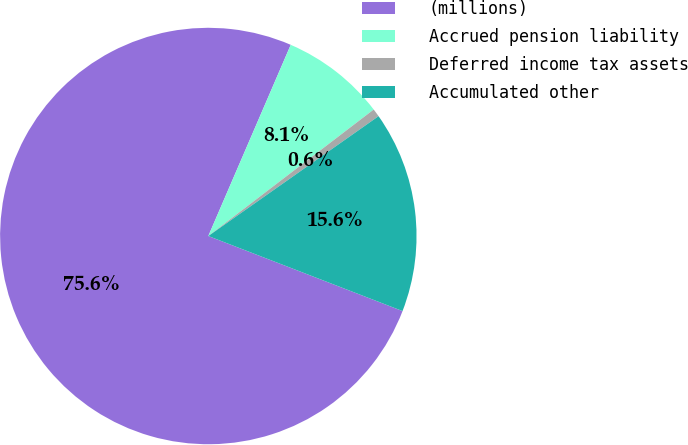<chart> <loc_0><loc_0><loc_500><loc_500><pie_chart><fcel>(millions)<fcel>Accrued pension liability<fcel>Deferred income tax assets<fcel>Accumulated other<nl><fcel>75.61%<fcel>8.13%<fcel>0.63%<fcel>15.63%<nl></chart> 